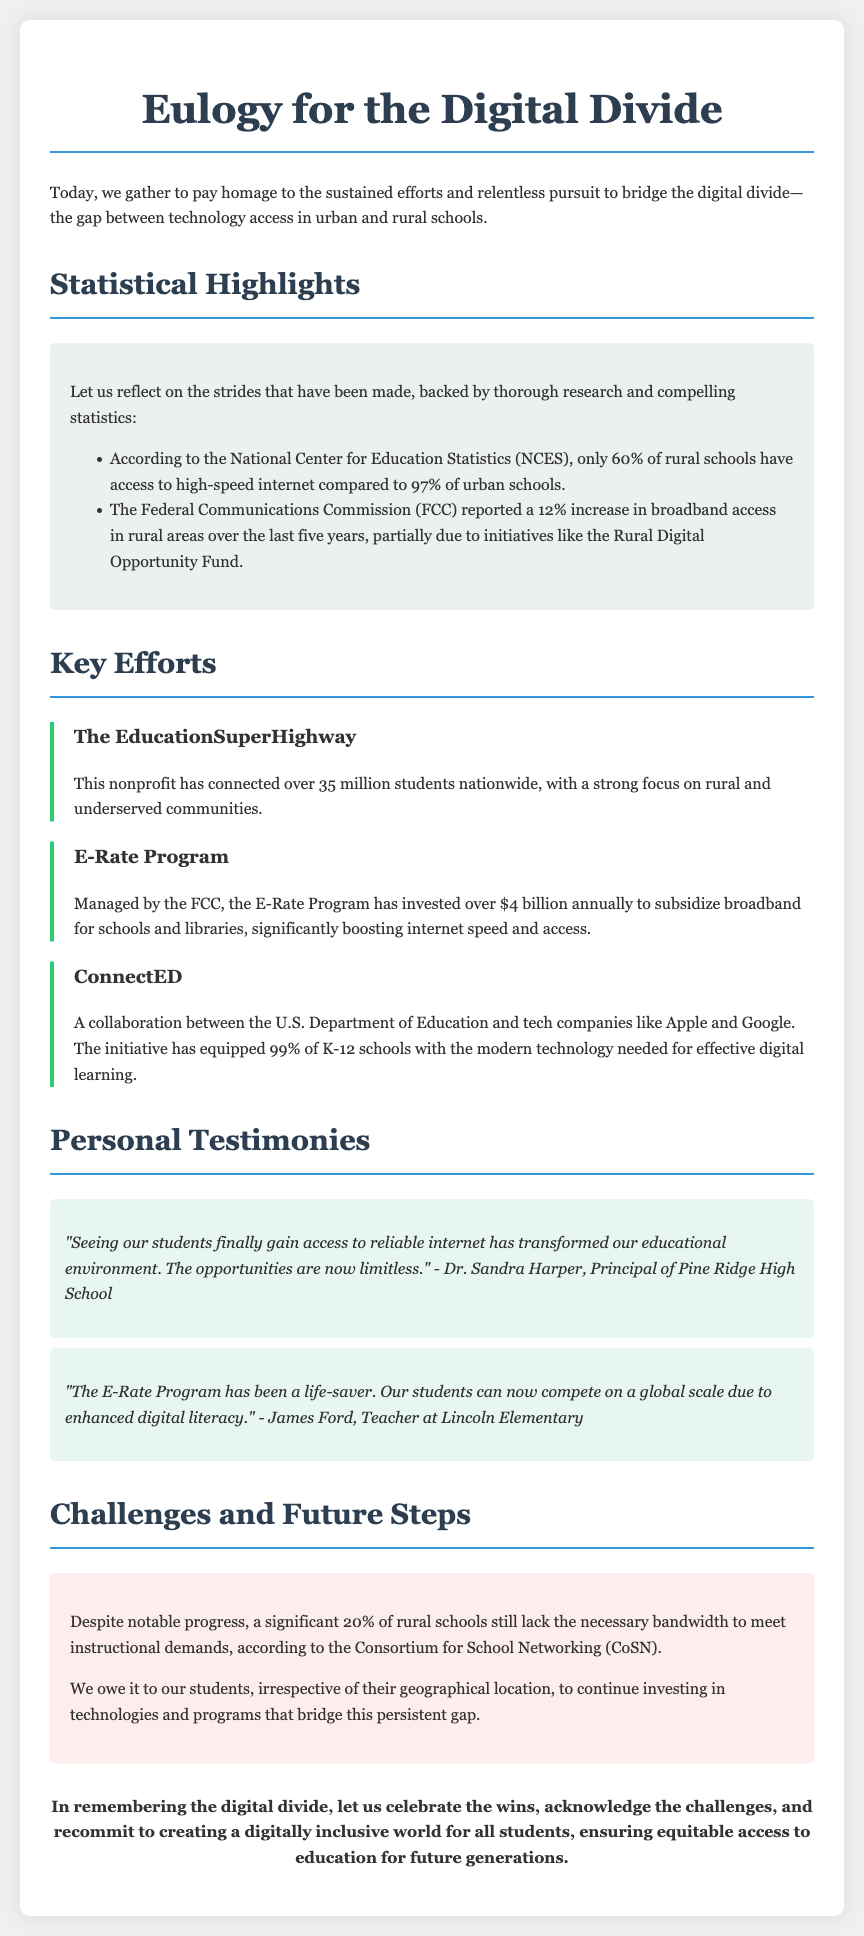What percentage of rural schools have access to high-speed internet? The document states that only 60% of rural schools have access to high-speed internet.
Answer: 60% What initiative reported a 12% increase in broadband access in rural areas? The initiative mentioned is the Rural Digital Opportunity Fund, as reported by the FCC in the document.
Answer: Rural Digital Opportunity Fund How many students has EducationSuperHighway connected nationwide? According to the document, EducationSuperHighway has connected over 35 million students nationwide.
Answer: 35 million What is the annual investment of the E-Rate Program? The document notes that the E-Rate Program has invested over $4 billion annually.
Answer: Over $4 billion What percentage of K-12 schools has been equipped with modern technology through ConnectED? The document mentions that ConnectED has equipped 99% of K-12 schools with modern technology.
Answer: 99% What challenge does 20% of rural schools face according to the Consortium for School Networking? The document states that 20% of rural schools lack the necessary bandwidth to meet instructional demands.
Answer: Lack of bandwidth Who is the principal of Pine Ridge High School? The document mentions that Dr. Sandra Harper is the principal of Pine Ridge High School.
Answer: Dr. Sandra Harper What is the closing statement's main call to action? The closing statement urges a recommitment to creating a digitally inclusive world for all students.
Answer: Recommit to creating a digitally inclusive world What is the main theme of the document? The document's main theme focuses on the efforts to bridge the digital divide between urban and rural schools.
Answer: Bridging the digital divide 